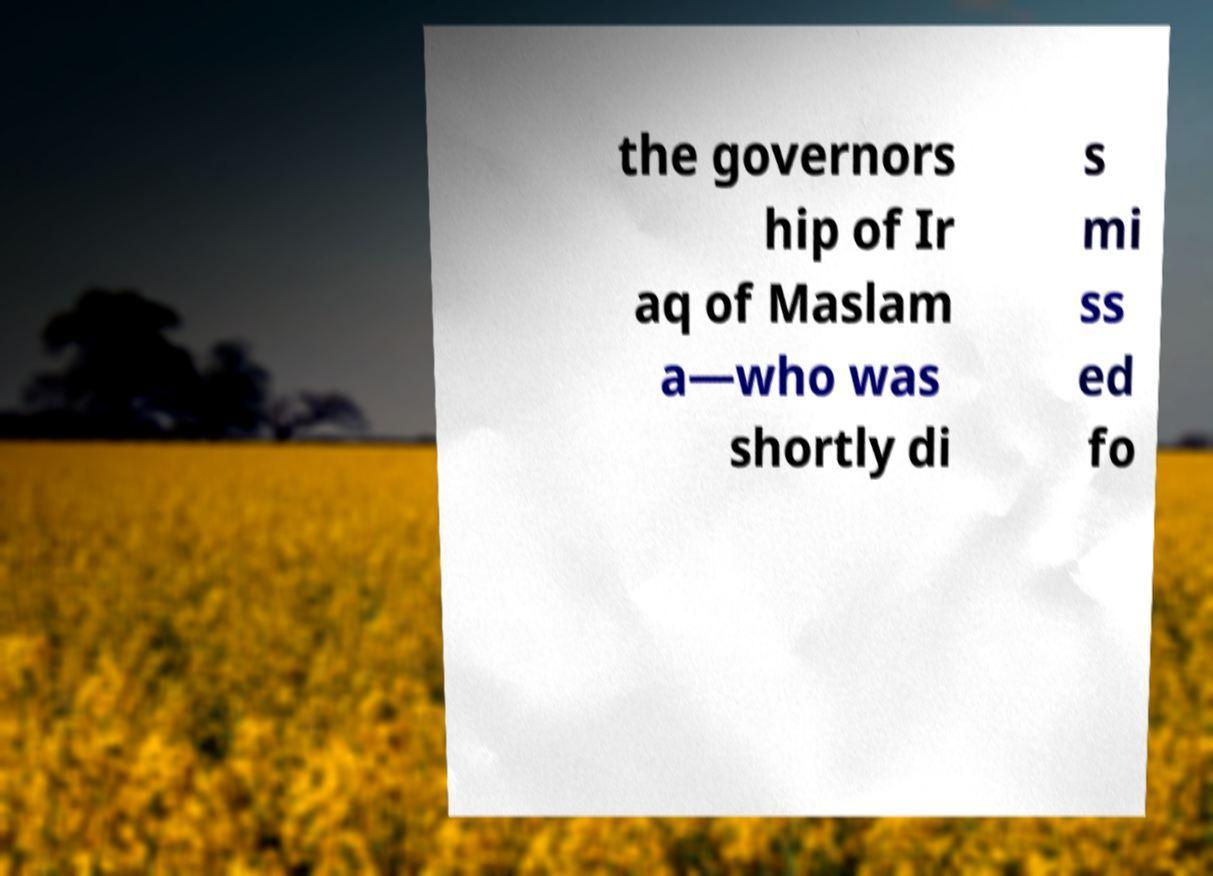I need the written content from this picture converted into text. Can you do that? the governors hip of Ir aq of Maslam a—who was shortly di s mi ss ed fo 